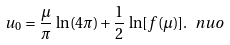Convert formula to latex. <formula><loc_0><loc_0><loc_500><loc_500>u _ { 0 } = \frac { \mu } { \pi } \, \ln ( 4 \pi ) + \frac { 1 } { 2 } \, \ln [ f ( \mu ) ] . \ n { u o }</formula> 